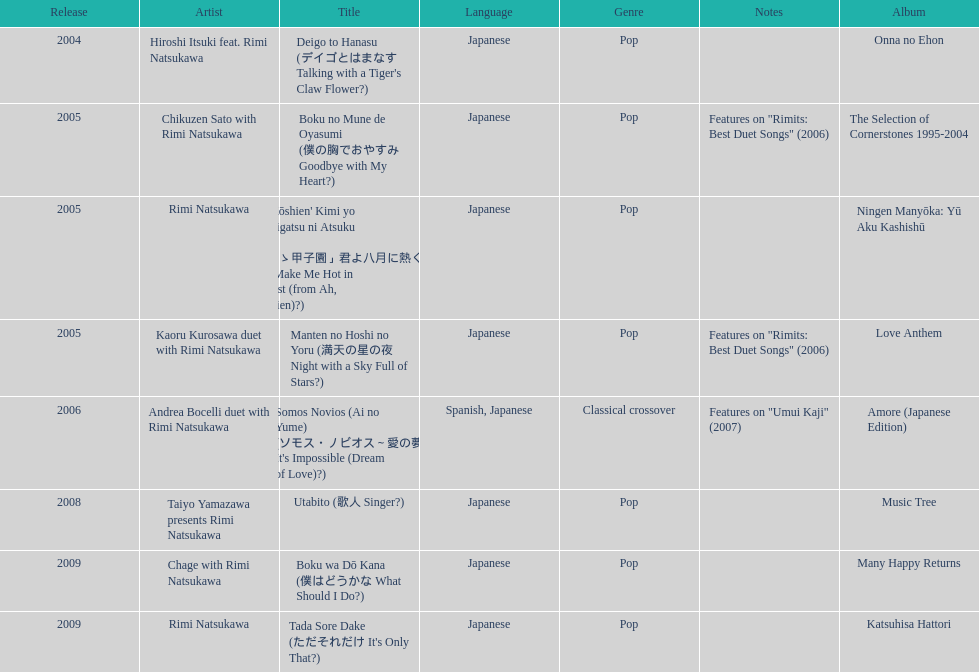Which was not released in 2004, onna no ehon or music tree? Music Tree. 